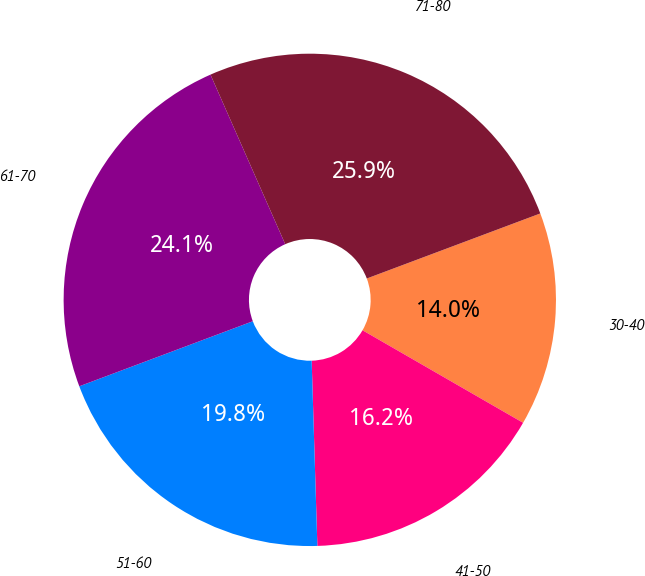<chart> <loc_0><loc_0><loc_500><loc_500><pie_chart><fcel>30-40<fcel>41-50<fcel>51-60<fcel>61-70<fcel>71-80<nl><fcel>14.03%<fcel>16.19%<fcel>19.78%<fcel>24.1%<fcel>25.9%<nl></chart> 